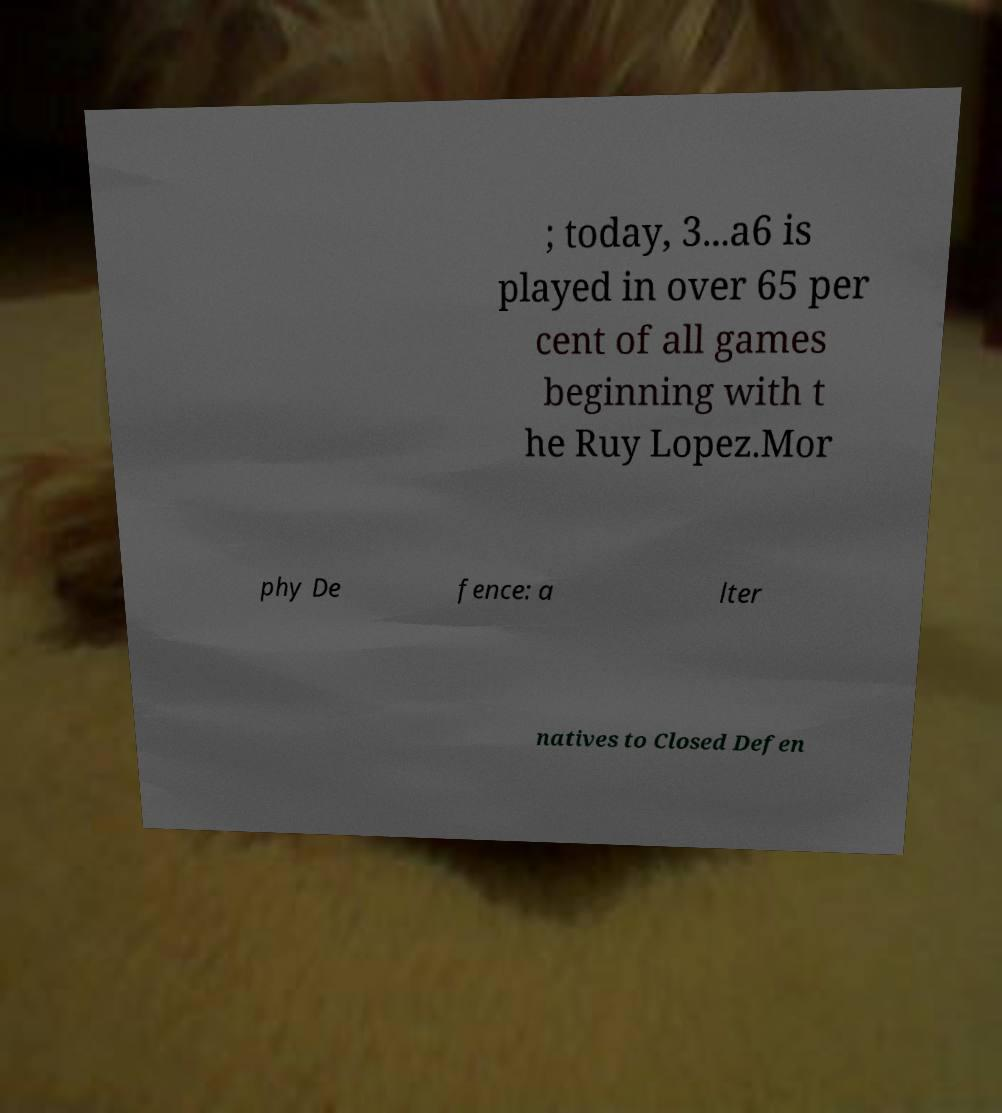Please read and relay the text visible in this image. What does it say? ; today, 3...a6 is played in over 65 per cent of all games beginning with t he Ruy Lopez.Mor phy De fence: a lter natives to Closed Defen 